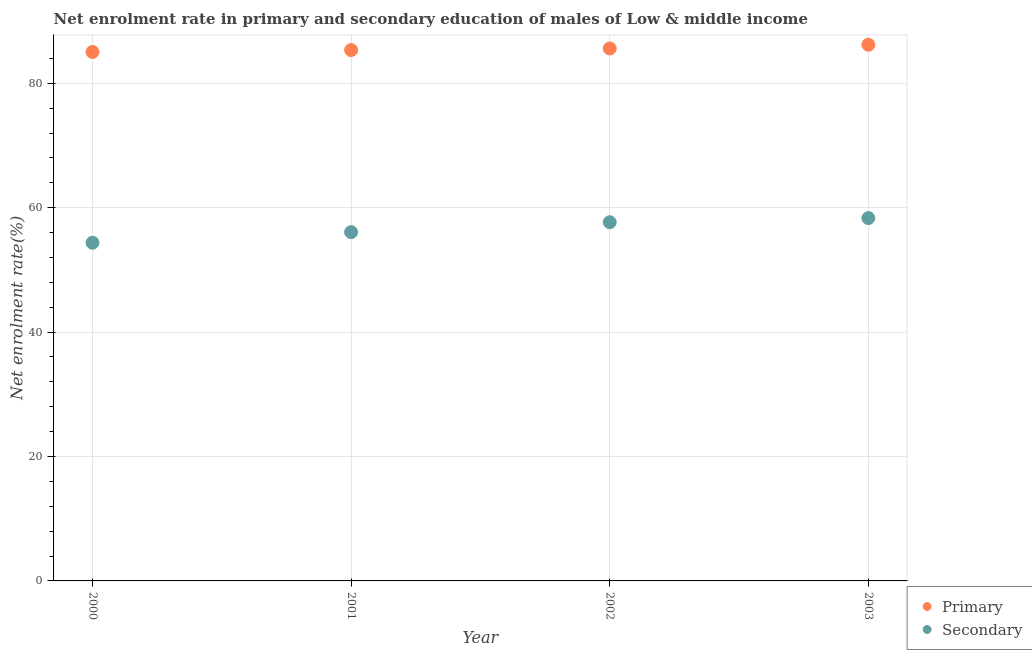What is the enrollment rate in primary education in 2003?
Provide a succinct answer. 86.19. Across all years, what is the maximum enrollment rate in secondary education?
Ensure brevity in your answer.  58.33. Across all years, what is the minimum enrollment rate in secondary education?
Your answer should be very brief. 54.36. What is the total enrollment rate in primary education in the graph?
Ensure brevity in your answer.  342.16. What is the difference between the enrollment rate in primary education in 2001 and that in 2003?
Provide a short and direct response. -0.85. What is the difference between the enrollment rate in primary education in 2003 and the enrollment rate in secondary education in 2000?
Keep it short and to the point. 31.83. What is the average enrollment rate in secondary education per year?
Offer a terse response. 56.61. In the year 2001, what is the difference between the enrollment rate in secondary education and enrollment rate in primary education?
Your response must be concise. -29.27. What is the ratio of the enrollment rate in primary education in 2000 to that in 2001?
Keep it short and to the point. 1. Is the enrollment rate in secondary education in 2002 less than that in 2003?
Ensure brevity in your answer.  Yes. Is the difference between the enrollment rate in secondary education in 2000 and 2001 greater than the difference between the enrollment rate in primary education in 2000 and 2001?
Your answer should be very brief. No. What is the difference between the highest and the second highest enrollment rate in primary education?
Offer a terse response. 0.59. What is the difference between the highest and the lowest enrollment rate in secondary education?
Ensure brevity in your answer.  3.97. In how many years, is the enrollment rate in secondary education greater than the average enrollment rate in secondary education taken over all years?
Your response must be concise. 2. Does the enrollment rate in primary education monotonically increase over the years?
Ensure brevity in your answer.  Yes. How many legend labels are there?
Give a very brief answer. 2. What is the title of the graph?
Provide a short and direct response. Net enrolment rate in primary and secondary education of males of Low & middle income. What is the label or title of the Y-axis?
Offer a very short reply. Net enrolment rate(%). What is the Net enrolment rate(%) in Primary in 2000?
Give a very brief answer. 85.03. What is the Net enrolment rate(%) in Secondary in 2000?
Offer a very short reply. 54.36. What is the Net enrolment rate(%) of Primary in 2001?
Your response must be concise. 85.34. What is the Net enrolment rate(%) of Secondary in 2001?
Offer a terse response. 56.07. What is the Net enrolment rate(%) of Primary in 2002?
Your answer should be compact. 85.6. What is the Net enrolment rate(%) in Secondary in 2002?
Your answer should be compact. 57.66. What is the Net enrolment rate(%) in Primary in 2003?
Offer a very short reply. 86.19. What is the Net enrolment rate(%) of Secondary in 2003?
Keep it short and to the point. 58.33. Across all years, what is the maximum Net enrolment rate(%) of Primary?
Your response must be concise. 86.19. Across all years, what is the maximum Net enrolment rate(%) in Secondary?
Give a very brief answer. 58.33. Across all years, what is the minimum Net enrolment rate(%) in Primary?
Offer a very short reply. 85.03. Across all years, what is the minimum Net enrolment rate(%) of Secondary?
Ensure brevity in your answer.  54.36. What is the total Net enrolment rate(%) of Primary in the graph?
Give a very brief answer. 342.16. What is the total Net enrolment rate(%) of Secondary in the graph?
Provide a short and direct response. 226.42. What is the difference between the Net enrolment rate(%) of Primary in 2000 and that in 2001?
Offer a very short reply. -0.31. What is the difference between the Net enrolment rate(%) in Secondary in 2000 and that in 2001?
Ensure brevity in your answer.  -1.71. What is the difference between the Net enrolment rate(%) in Primary in 2000 and that in 2002?
Ensure brevity in your answer.  -0.56. What is the difference between the Net enrolment rate(%) of Secondary in 2000 and that in 2002?
Keep it short and to the point. -3.3. What is the difference between the Net enrolment rate(%) of Primary in 2000 and that in 2003?
Provide a short and direct response. -1.16. What is the difference between the Net enrolment rate(%) in Secondary in 2000 and that in 2003?
Ensure brevity in your answer.  -3.97. What is the difference between the Net enrolment rate(%) of Primary in 2001 and that in 2002?
Your answer should be compact. -0.26. What is the difference between the Net enrolment rate(%) of Secondary in 2001 and that in 2002?
Offer a very short reply. -1.59. What is the difference between the Net enrolment rate(%) of Primary in 2001 and that in 2003?
Make the answer very short. -0.85. What is the difference between the Net enrolment rate(%) of Secondary in 2001 and that in 2003?
Your answer should be compact. -2.26. What is the difference between the Net enrolment rate(%) in Primary in 2002 and that in 2003?
Provide a short and direct response. -0.59. What is the difference between the Net enrolment rate(%) in Secondary in 2002 and that in 2003?
Offer a terse response. -0.67. What is the difference between the Net enrolment rate(%) in Primary in 2000 and the Net enrolment rate(%) in Secondary in 2001?
Keep it short and to the point. 28.96. What is the difference between the Net enrolment rate(%) of Primary in 2000 and the Net enrolment rate(%) of Secondary in 2002?
Your answer should be compact. 27.37. What is the difference between the Net enrolment rate(%) of Primary in 2000 and the Net enrolment rate(%) of Secondary in 2003?
Provide a succinct answer. 26.7. What is the difference between the Net enrolment rate(%) in Primary in 2001 and the Net enrolment rate(%) in Secondary in 2002?
Your answer should be compact. 27.68. What is the difference between the Net enrolment rate(%) of Primary in 2001 and the Net enrolment rate(%) of Secondary in 2003?
Provide a short and direct response. 27.01. What is the difference between the Net enrolment rate(%) of Primary in 2002 and the Net enrolment rate(%) of Secondary in 2003?
Offer a terse response. 27.27. What is the average Net enrolment rate(%) in Primary per year?
Your answer should be very brief. 85.54. What is the average Net enrolment rate(%) in Secondary per year?
Offer a terse response. 56.61. In the year 2000, what is the difference between the Net enrolment rate(%) in Primary and Net enrolment rate(%) in Secondary?
Ensure brevity in your answer.  30.67. In the year 2001, what is the difference between the Net enrolment rate(%) in Primary and Net enrolment rate(%) in Secondary?
Provide a short and direct response. 29.27. In the year 2002, what is the difference between the Net enrolment rate(%) in Primary and Net enrolment rate(%) in Secondary?
Keep it short and to the point. 27.94. In the year 2003, what is the difference between the Net enrolment rate(%) of Primary and Net enrolment rate(%) of Secondary?
Offer a very short reply. 27.86. What is the ratio of the Net enrolment rate(%) of Secondary in 2000 to that in 2001?
Provide a short and direct response. 0.97. What is the ratio of the Net enrolment rate(%) of Primary in 2000 to that in 2002?
Ensure brevity in your answer.  0.99. What is the ratio of the Net enrolment rate(%) in Secondary in 2000 to that in 2002?
Keep it short and to the point. 0.94. What is the ratio of the Net enrolment rate(%) of Primary in 2000 to that in 2003?
Offer a very short reply. 0.99. What is the ratio of the Net enrolment rate(%) in Secondary in 2000 to that in 2003?
Give a very brief answer. 0.93. What is the ratio of the Net enrolment rate(%) in Secondary in 2001 to that in 2002?
Offer a very short reply. 0.97. What is the ratio of the Net enrolment rate(%) in Primary in 2001 to that in 2003?
Offer a terse response. 0.99. What is the ratio of the Net enrolment rate(%) of Secondary in 2001 to that in 2003?
Offer a very short reply. 0.96. What is the ratio of the Net enrolment rate(%) in Secondary in 2002 to that in 2003?
Ensure brevity in your answer.  0.99. What is the difference between the highest and the second highest Net enrolment rate(%) of Primary?
Offer a terse response. 0.59. What is the difference between the highest and the second highest Net enrolment rate(%) in Secondary?
Provide a short and direct response. 0.67. What is the difference between the highest and the lowest Net enrolment rate(%) of Primary?
Offer a terse response. 1.16. What is the difference between the highest and the lowest Net enrolment rate(%) of Secondary?
Provide a succinct answer. 3.97. 